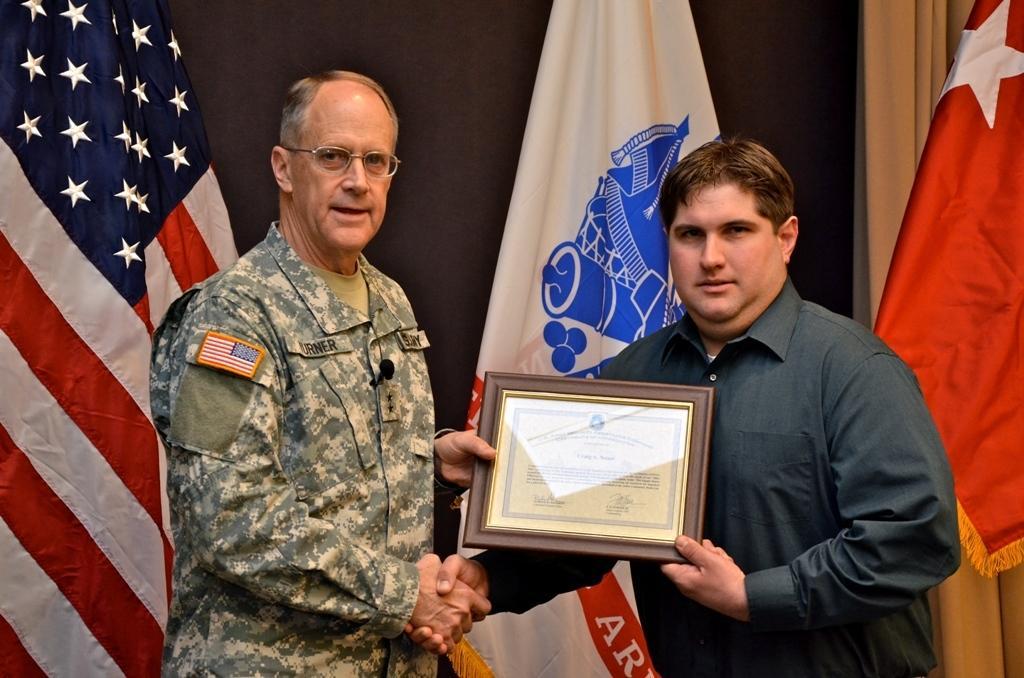In one or two sentences, can you explain what this image depicts? In the image we can see two men standing, wearing clothes and the left side man is wearing spectacles. They are holding the frame. Behind them there are flags of the countries. 